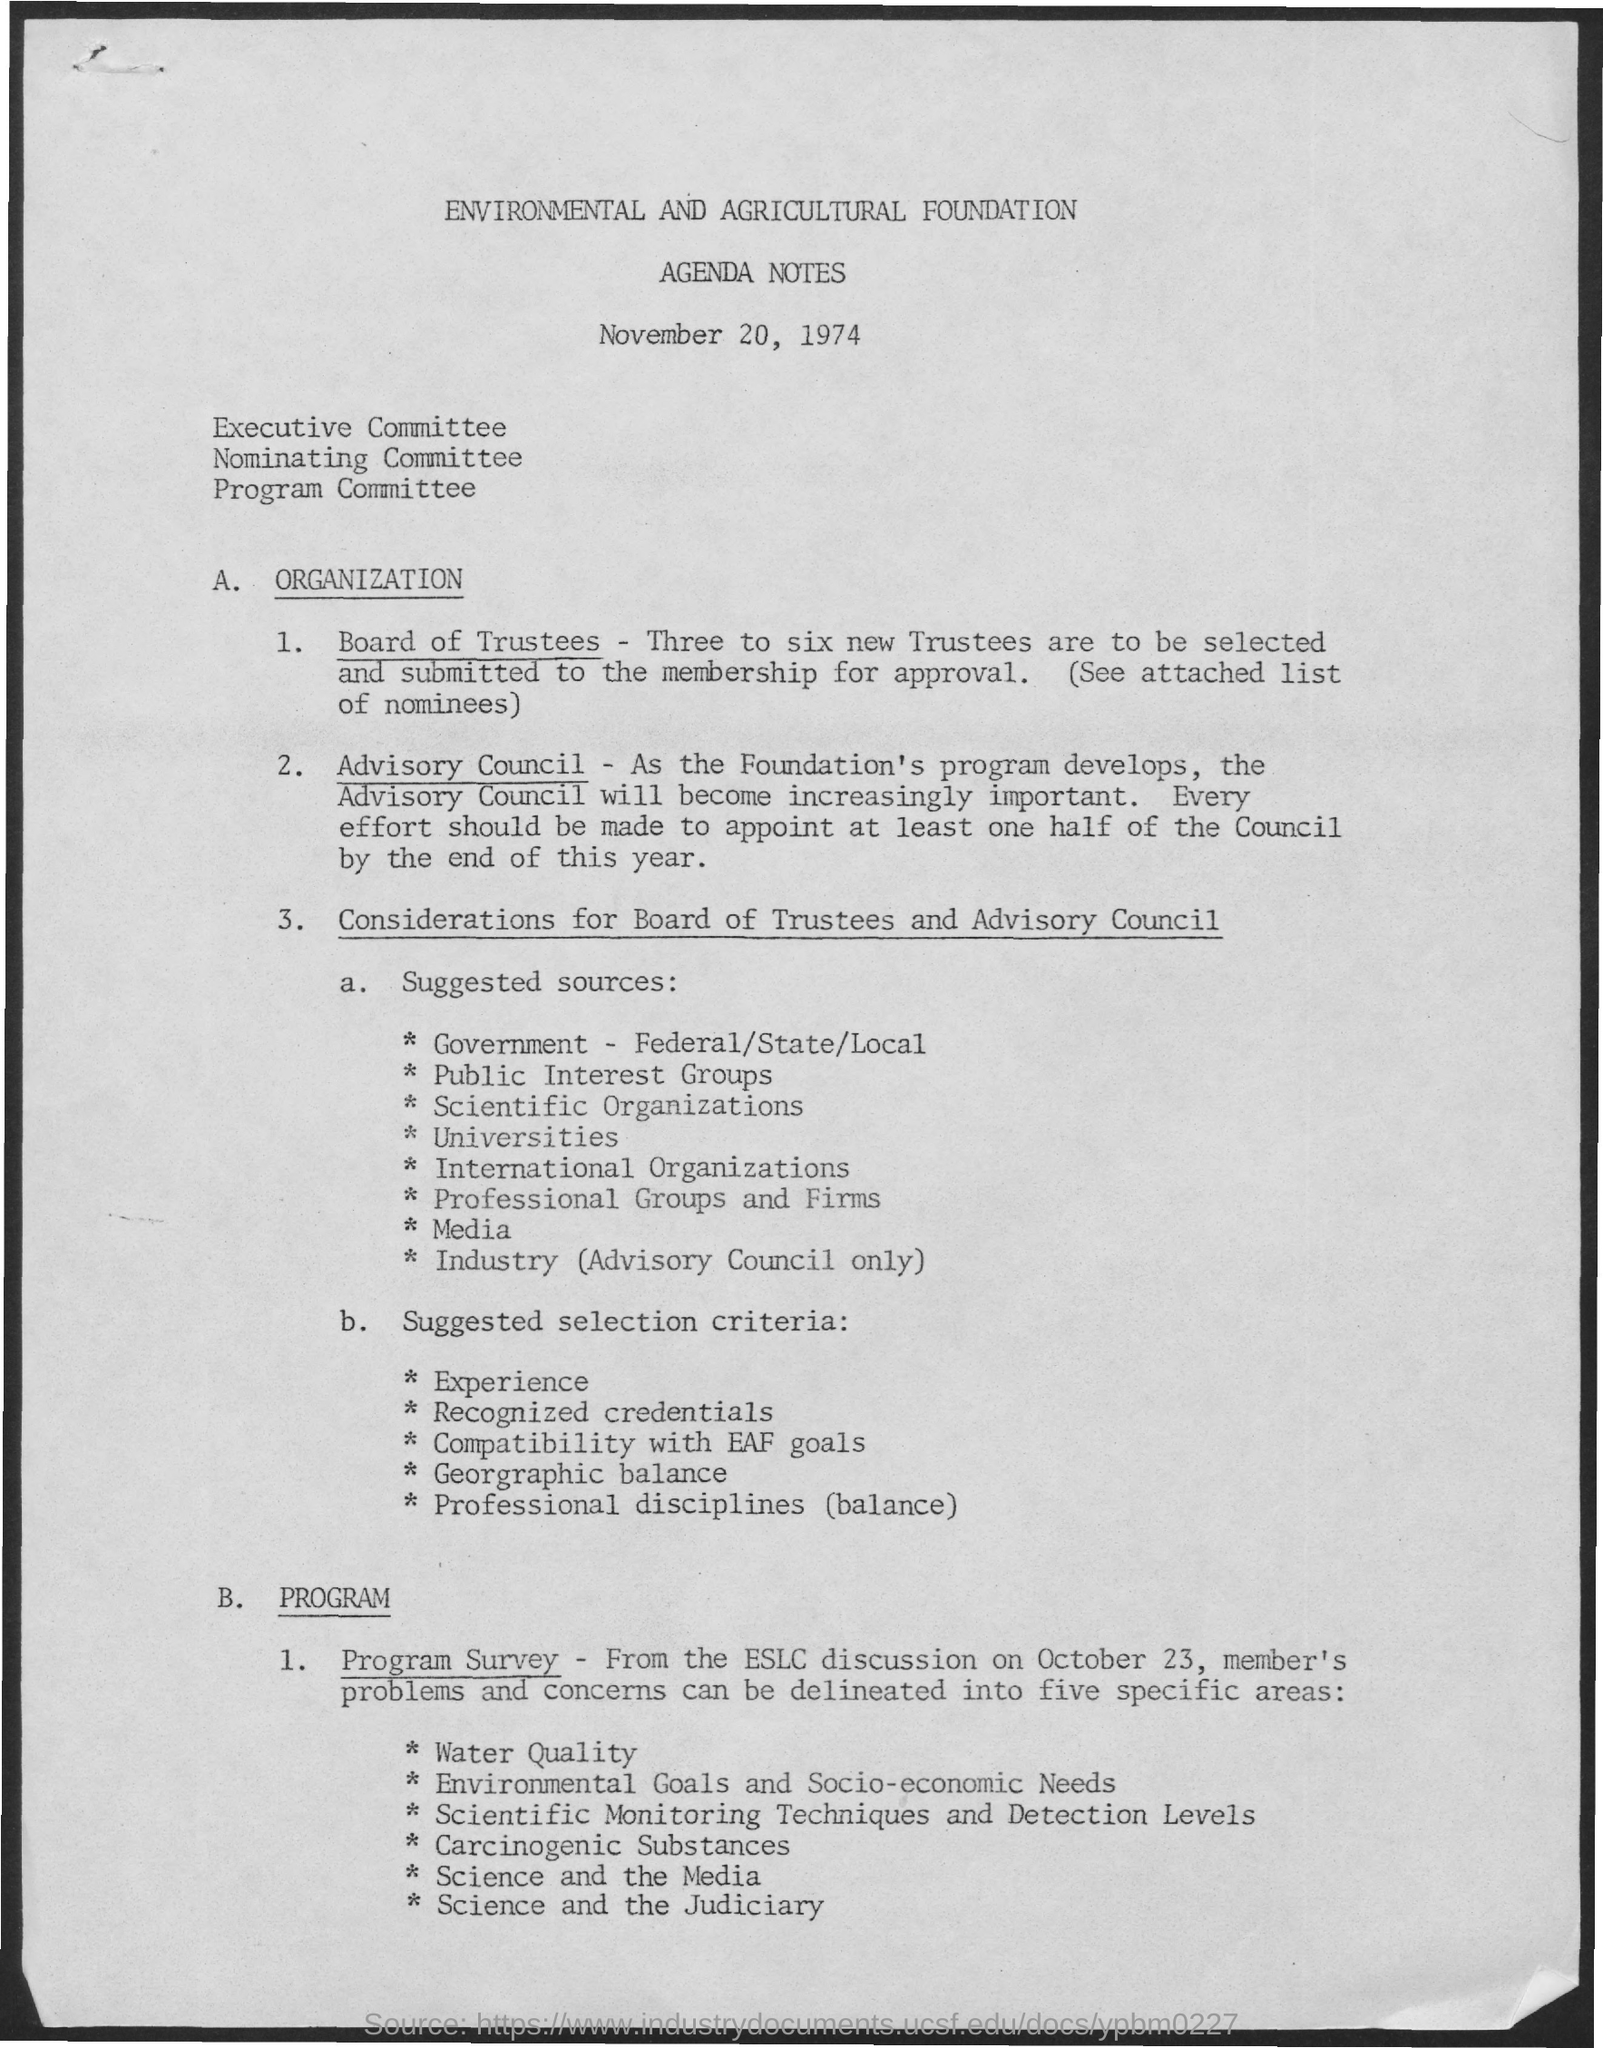List a handful of essential elements in this visual. AGENDA NOTES is the second title in the document. 